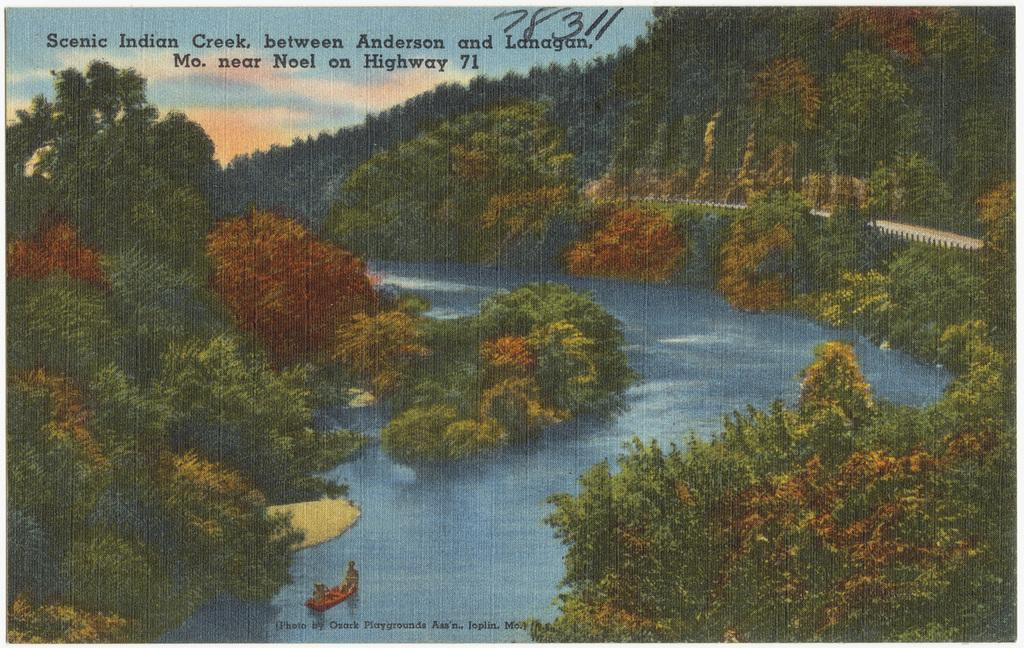What type of natural feature is depicted in the image? There is a river in the image. What can be seen around the river? Trees are present around the river. What other geographical features are visible in the image? There are hills visible in the image. What type of furniture can be seen in the bedroom in the image? There is no bedroom present in the image; it features a river, trees, and hills. 